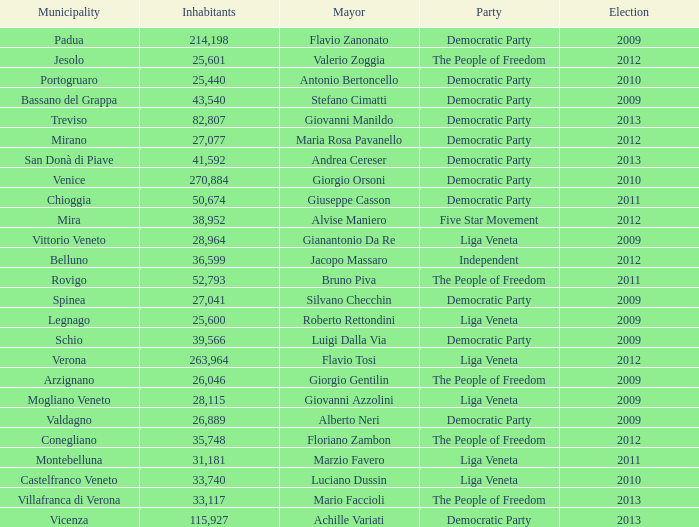Could you parse the entire table as a dict? {'header': ['Municipality', 'Inhabitants', 'Mayor', 'Party', 'Election'], 'rows': [['Padua', '214,198', 'Flavio Zanonato', 'Democratic Party', '2009'], ['Jesolo', '25,601', 'Valerio Zoggia', 'The People of Freedom', '2012'], ['Portogruaro', '25,440', 'Antonio Bertoncello', 'Democratic Party', '2010'], ['Bassano del Grappa', '43,540', 'Stefano Cimatti', 'Democratic Party', '2009'], ['Treviso', '82,807', 'Giovanni Manildo', 'Democratic Party', '2013'], ['Mirano', '27,077', 'Maria Rosa Pavanello', 'Democratic Party', '2012'], ['San Donà di Piave', '41,592', 'Andrea Cereser', 'Democratic Party', '2013'], ['Venice', '270,884', 'Giorgio Orsoni', 'Democratic Party', '2010'], ['Chioggia', '50,674', 'Giuseppe Casson', 'Democratic Party', '2011'], ['Mira', '38,952', 'Alvise Maniero', 'Five Star Movement', '2012'], ['Vittorio Veneto', '28,964', 'Gianantonio Da Re', 'Liga Veneta', '2009'], ['Belluno', '36,599', 'Jacopo Massaro', 'Independent', '2012'], ['Rovigo', '52,793', 'Bruno Piva', 'The People of Freedom', '2011'], ['Spinea', '27,041', 'Silvano Checchin', 'Democratic Party', '2009'], ['Legnago', '25,600', 'Roberto Rettondini', 'Liga Veneta', '2009'], ['Schio', '39,566', 'Luigi Dalla Via', 'Democratic Party', '2009'], ['Verona', '263,964', 'Flavio Tosi', 'Liga Veneta', '2012'], ['Arzignano', '26,046', 'Giorgio Gentilin', 'The People of Freedom', '2009'], ['Mogliano Veneto', '28,115', 'Giovanni Azzolini', 'Liga Veneta', '2009'], ['Valdagno', '26,889', 'Alberto Neri', 'Democratic Party', '2009'], ['Conegliano', '35,748', 'Floriano Zambon', 'The People of Freedom', '2012'], ['Montebelluna', '31,181', 'Marzio Favero', 'Liga Veneta', '2011'], ['Castelfranco Veneto', '33,740', 'Luciano Dussin', 'Liga Veneta', '2010'], ['Villafranca di Verona', '33,117', 'Mario Faccioli', 'The People of Freedom', '2013'], ['Vicenza', '115,927', 'Achille Variati', 'Democratic Party', '2013']]} How many elections had more than 36,599 inhabitants when Mayor was giovanni manildo? 1.0. 